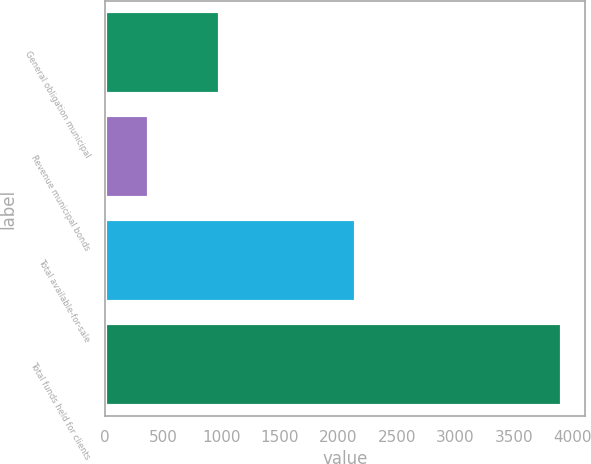Convert chart to OTSL. <chart><loc_0><loc_0><loc_500><loc_500><bar_chart><fcel>General obligation municipal<fcel>Revenue municipal bonds<fcel>Total available-for-sale<fcel>Total funds held for clients<nl><fcel>984.5<fcel>381.7<fcel>2151.8<fcel>3913.6<nl></chart> 